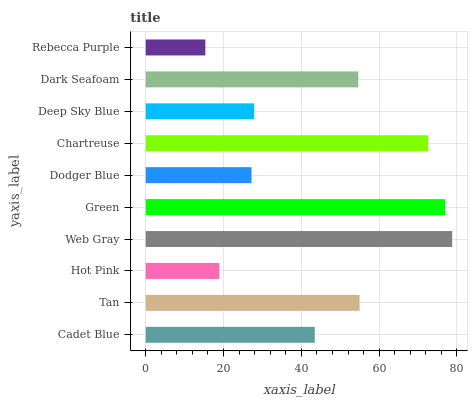Is Rebecca Purple the minimum?
Answer yes or no. Yes. Is Web Gray the maximum?
Answer yes or no. Yes. Is Tan the minimum?
Answer yes or no. No. Is Tan the maximum?
Answer yes or no. No. Is Tan greater than Cadet Blue?
Answer yes or no. Yes. Is Cadet Blue less than Tan?
Answer yes or no. Yes. Is Cadet Blue greater than Tan?
Answer yes or no. No. Is Tan less than Cadet Blue?
Answer yes or no. No. Is Dark Seafoam the high median?
Answer yes or no. Yes. Is Cadet Blue the low median?
Answer yes or no. Yes. Is Green the high median?
Answer yes or no. No. Is Green the low median?
Answer yes or no. No. 